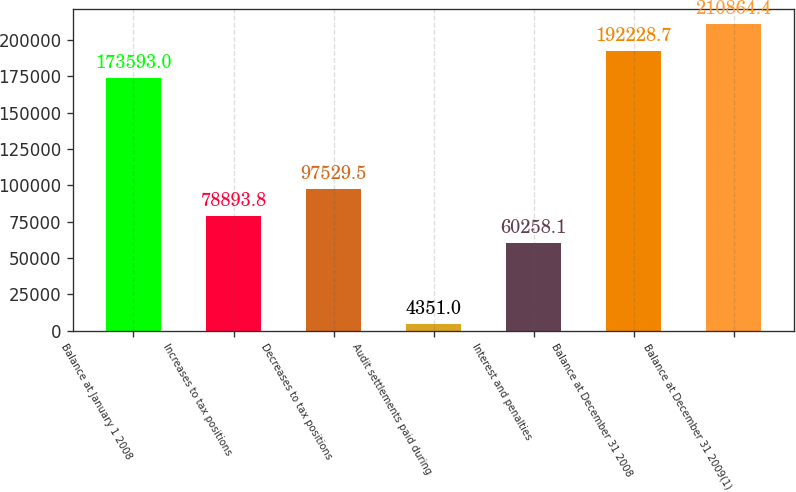<chart> <loc_0><loc_0><loc_500><loc_500><bar_chart><fcel>Balance at January 1 2008<fcel>Increases to tax positions<fcel>Decreases to tax positions<fcel>Audit settlements paid during<fcel>Interest and penalties<fcel>Balance at December 31 2008<fcel>Balance at December 31 2009(1)<nl><fcel>173593<fcel>78893.8<fcel>97529.5<fcel>4351<fcel>60258.1<fcel>192229<fcel>210864<nl></chart> 